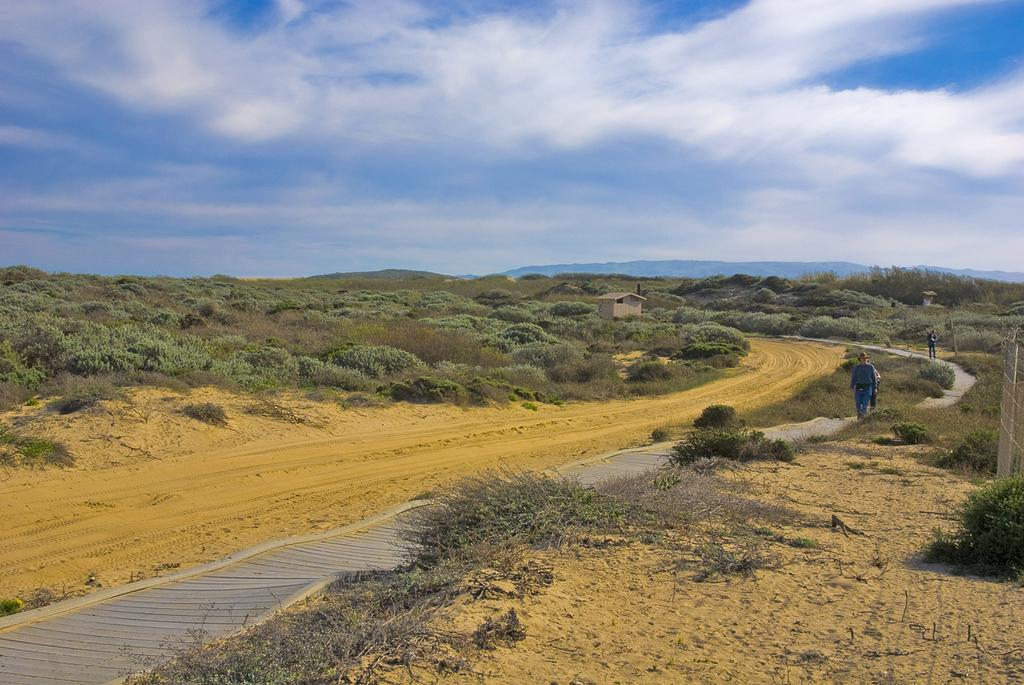What type of vegetation can be seen in the image? There is grass, plants, and trees in the image. What type of structures are present in the image? There are houses in the image. What is the boundary between the grass and the houses? There is a fence in the image. How many persons are visible in the image? There are three persons on the road in the image. What type of natural landmarks can be seen in the image? There are mountains in the image. What type of terrain is present in the image? There is sand in the image. What part of the natural environment is visible in the image? The sky is visible in the image. Based on the visible sky and the presence of people, what time of day might the image have been taken? The image was likely taken during the day. What type of lamp is visible on the sand in the image? There is no lamp present in the image. What mathematical operation is being performed by the persons on the road in the image? There is no indication of any mathematical operation being performed by the persons in the image. 